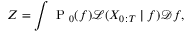<formula> <loc_0><loc_0><loc_500><loc_500>Z = \int P _ { 0 } ( f ) \mathcal { L } ( X _ { 0 \colon T } | f ) \mathcal { D } f ,</formula> 